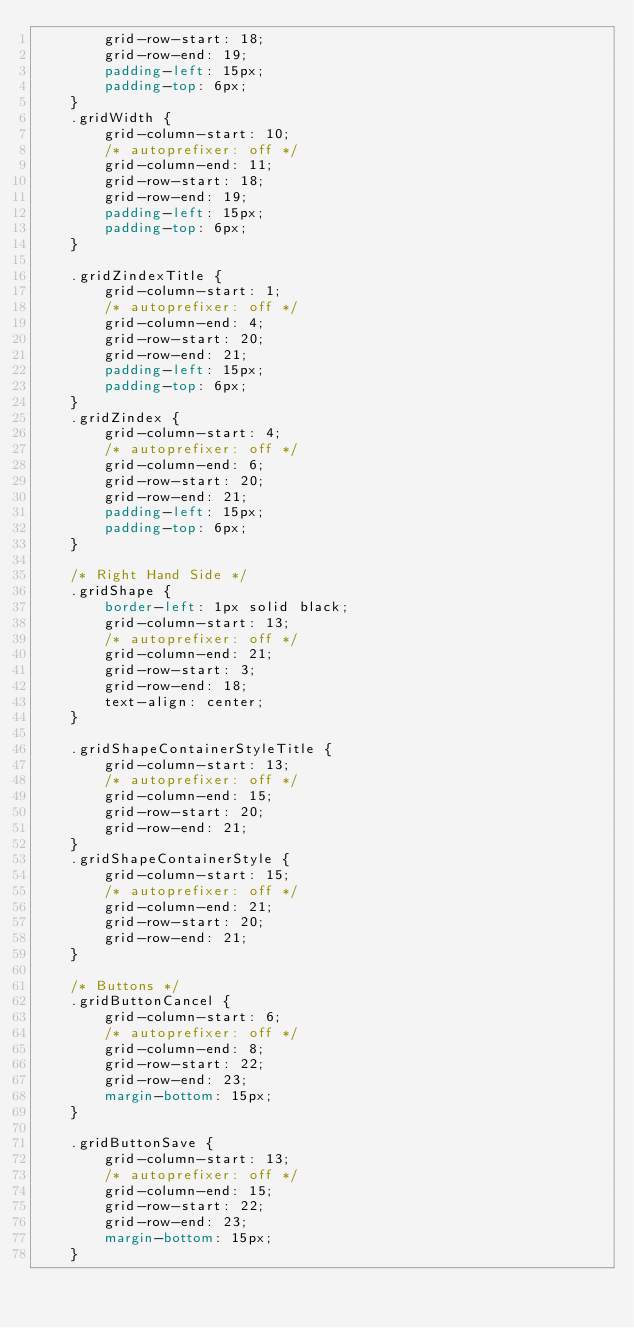Convert code to text. <code><loc_0><loc_0><loc_500><loc_500><_CSS_>        grid-row-start: 18;
        grid-row-end: 19;
        padding-left: 15px;
        padding-top: 6px;
    }
    .gridWidth {
        grid-column-start: 10;
        /* autoprefixer: off */
        grid-column-end: 11;
        grid-row-start: 18;
        grid-row-end: 19;
        padding-left: 15px;
        padding-top: 6px;
    }

    .gridZindexTitle {
        grid-column-start: 1;
        /* autoprefixer: off */
        grid-column-end: 4;
        grid-row-start: 20;
        grid-row-end: 21;
        padding-left: 15px;
        padding-top: 6px;
    }
    .gridZindex {
        grid-column-start: 4;
        /* autoprefixer: off */
        grid-column-end: 6;
        grid-row-start: 20;
        grid-row-end: 21;
        padding-left: 15px;
        padding-top: 6px;
    }

    /* Right Hand Side */
    .gridShape {
        border-left: 1px solid black;
        grid-column-start: 13;
        /* autoprefixer: off */
        grid-column-end: 21;
        grid-row-start: 3;
        grid-row-end: 18;
        text-align: center;
    }

    .gridShapeContainerStyleTitle {
        grid-column-start: 13;
        /* autoprefixer: off */
        grid-column-end: 15;
        grid-row-start: 20;
        grid-row-end: 21;
    }
    .gridShapeContainerStyle {
        grid-column-start: 15;
        /* autoprefixer: off */
        grid-column-end: 21;
        grid-row-start: 20;
        grid-row-end: 21;
    }

    /* Buttons */
    .gridButtonCancel {
        grid-column-start: 6;
        /* autoprefixer: off */
        grid-column-end: 8;
        grid-row-start: 22;
        grid-row-end: 23;
        margin-bottom: 15px;
    }

    .gridButtonSave {
        grid-column-start: 13;
        /* autoprefixer: off */
        grid-column-end: 15;
        grid-row-start: 22;
        grid-row-end: 23;
        margin-bottom: 15px;
    }

</code> 